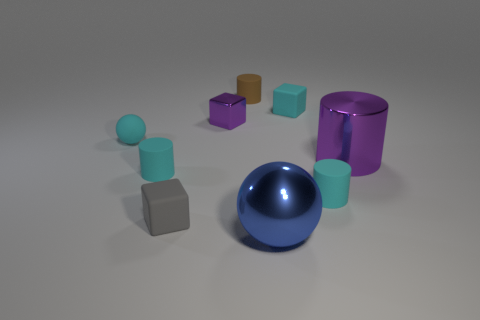Subtract all large cylinders. How many cylinders are left? 3 Subtract all blue spheres. How many spheres are left? 1 Subtract all blocks. How many objects are left? 6 Subtract 2 balls. How many balls are left? 0 Subtract all yellow metal blocks. Subtract all metallic cylinders. How many objects are left? 8 Add 8 tiny brown objects. How many tiny brown objects are left? 9 Add 6 small brown cylinders. How many small brown cylinders exist? 7 Subtract 0 yellow cylinders. How many objects are left? 9 Subtract all red balls. Subtract all yellow cubes. How many balls are left? 2 Subtract all cyan cylinders. How many purple balls are left? 0 